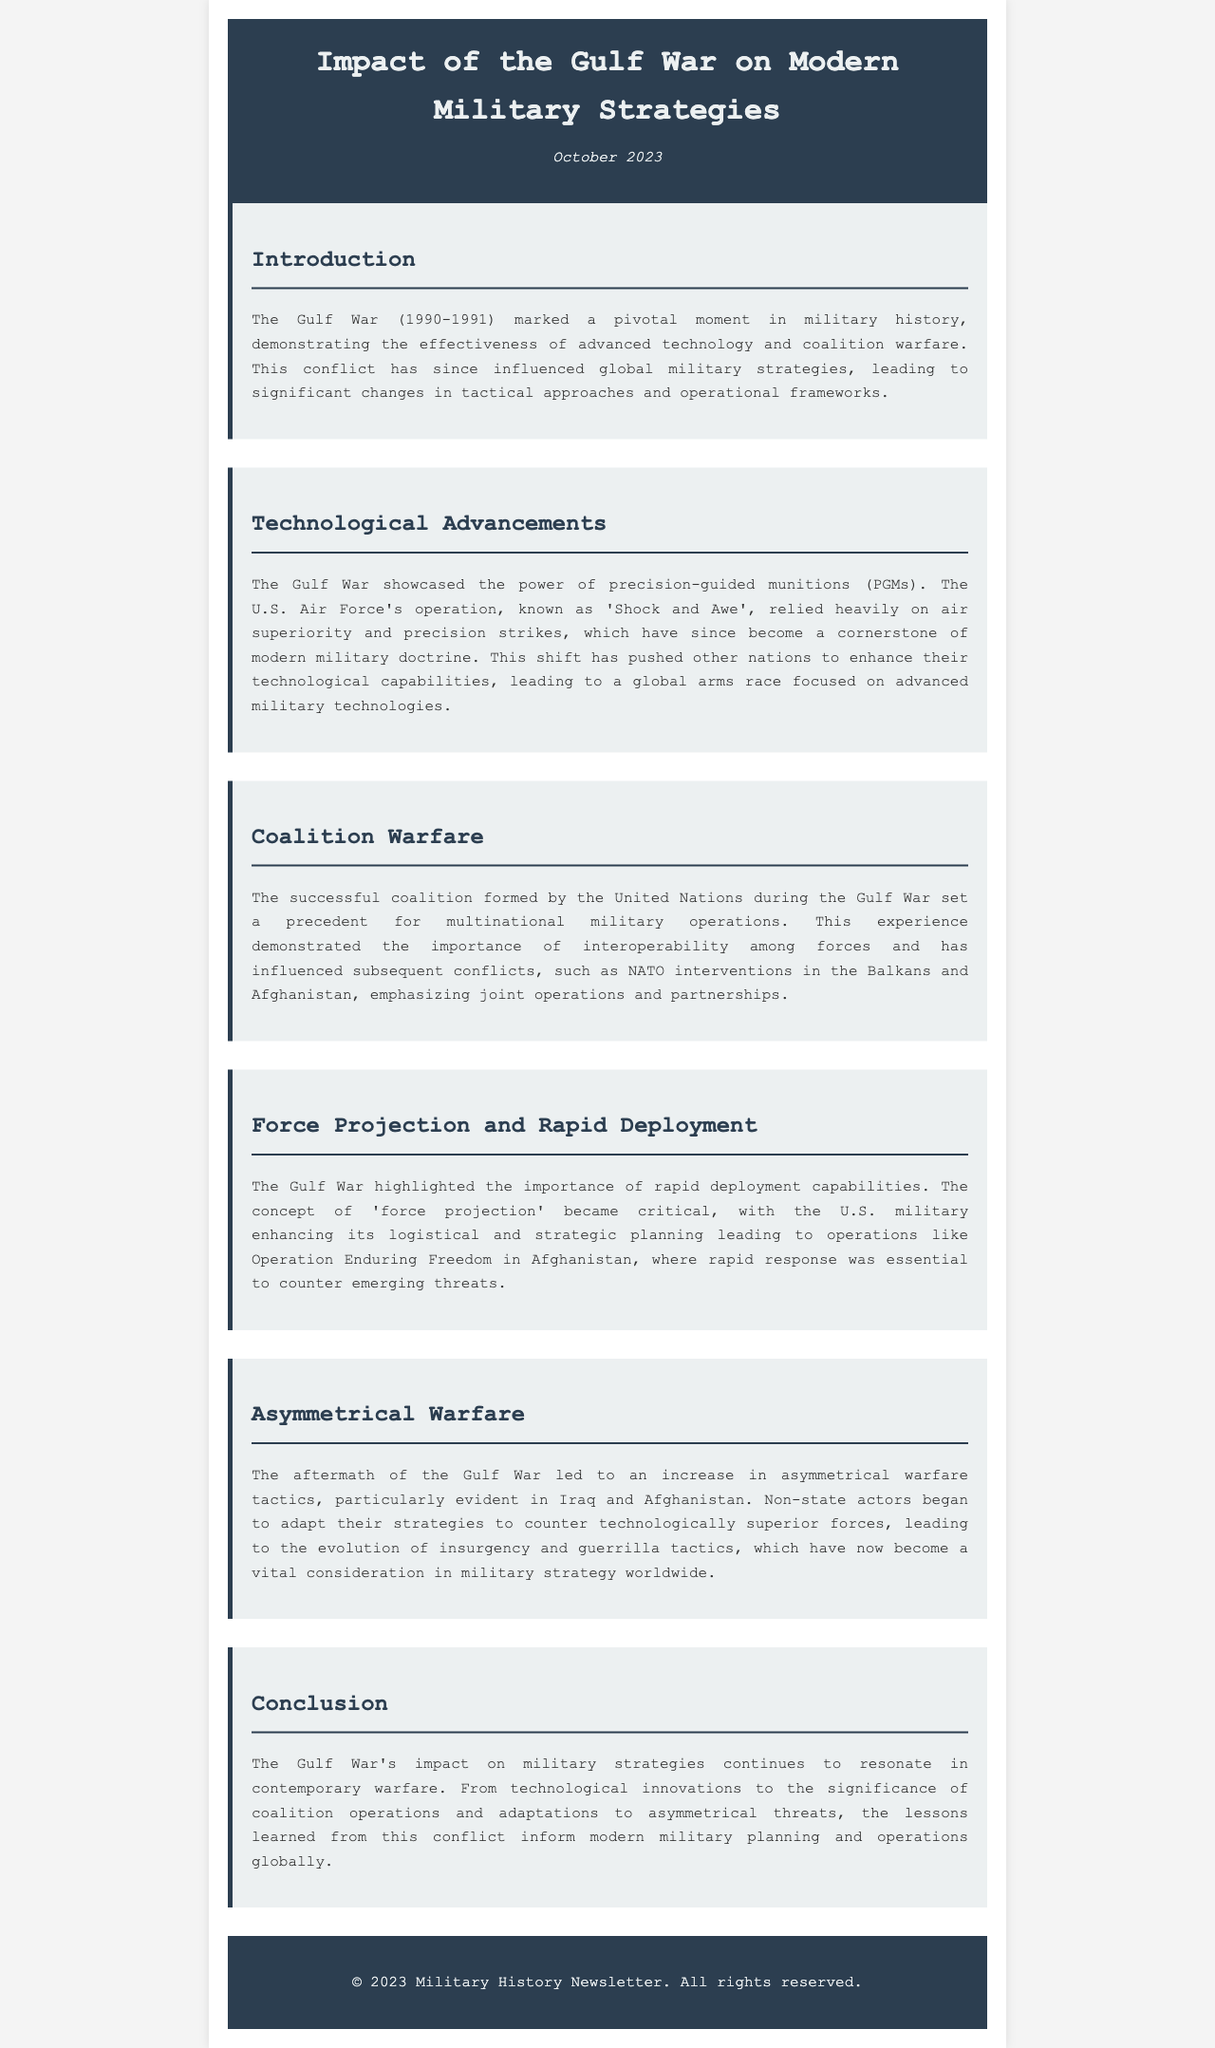What year did the Gulf War take place? The document states that the Gulf War occurred from 1990 to 1991.
Answer: 1990-1991 What operation is known for relying on air superiority and precision strikes? The document mentions 'Shock and Awe' as the operation that utilized air superiority and precision strikes during the Gulf War.
Answer: Shock and Awe What key capability was highlighted during the Gulf War regarding military logistics? The document emphasizes the importance of rapid deployment capabilities as a key outcome of the Gulf War.
Answer: Rapid deployment capabilities Which type of warfare increased after the Gulf War, particularly visible in Iraq and Afghanistan? The document discusses the rise of asymmetrical warfare tactics evolving in the aftermath of the Gulf War.
Answer: Asymmetrical warfare What did the Gulf War set a precedent for in terms of military operations? The document highlights that the successful coalition formed during the Gulf War set a precedent for multinational military operations.
Answer: Multinational military operations Which operation exemplified the importance of strategic planning in force projection following the Gulf War? The document states that Operation Enduring Freedom in Afghanistan represents the use of rapid response in terms of force projection.
Answer: Operation Enduring Freedom What type of actors adapted their strategies post-Gulf War to counter technologically superior forces? The document indicates that non-state actors began to adapt their strategies in response to superior forces after the Gulf War.
Answer: Non-state actors 